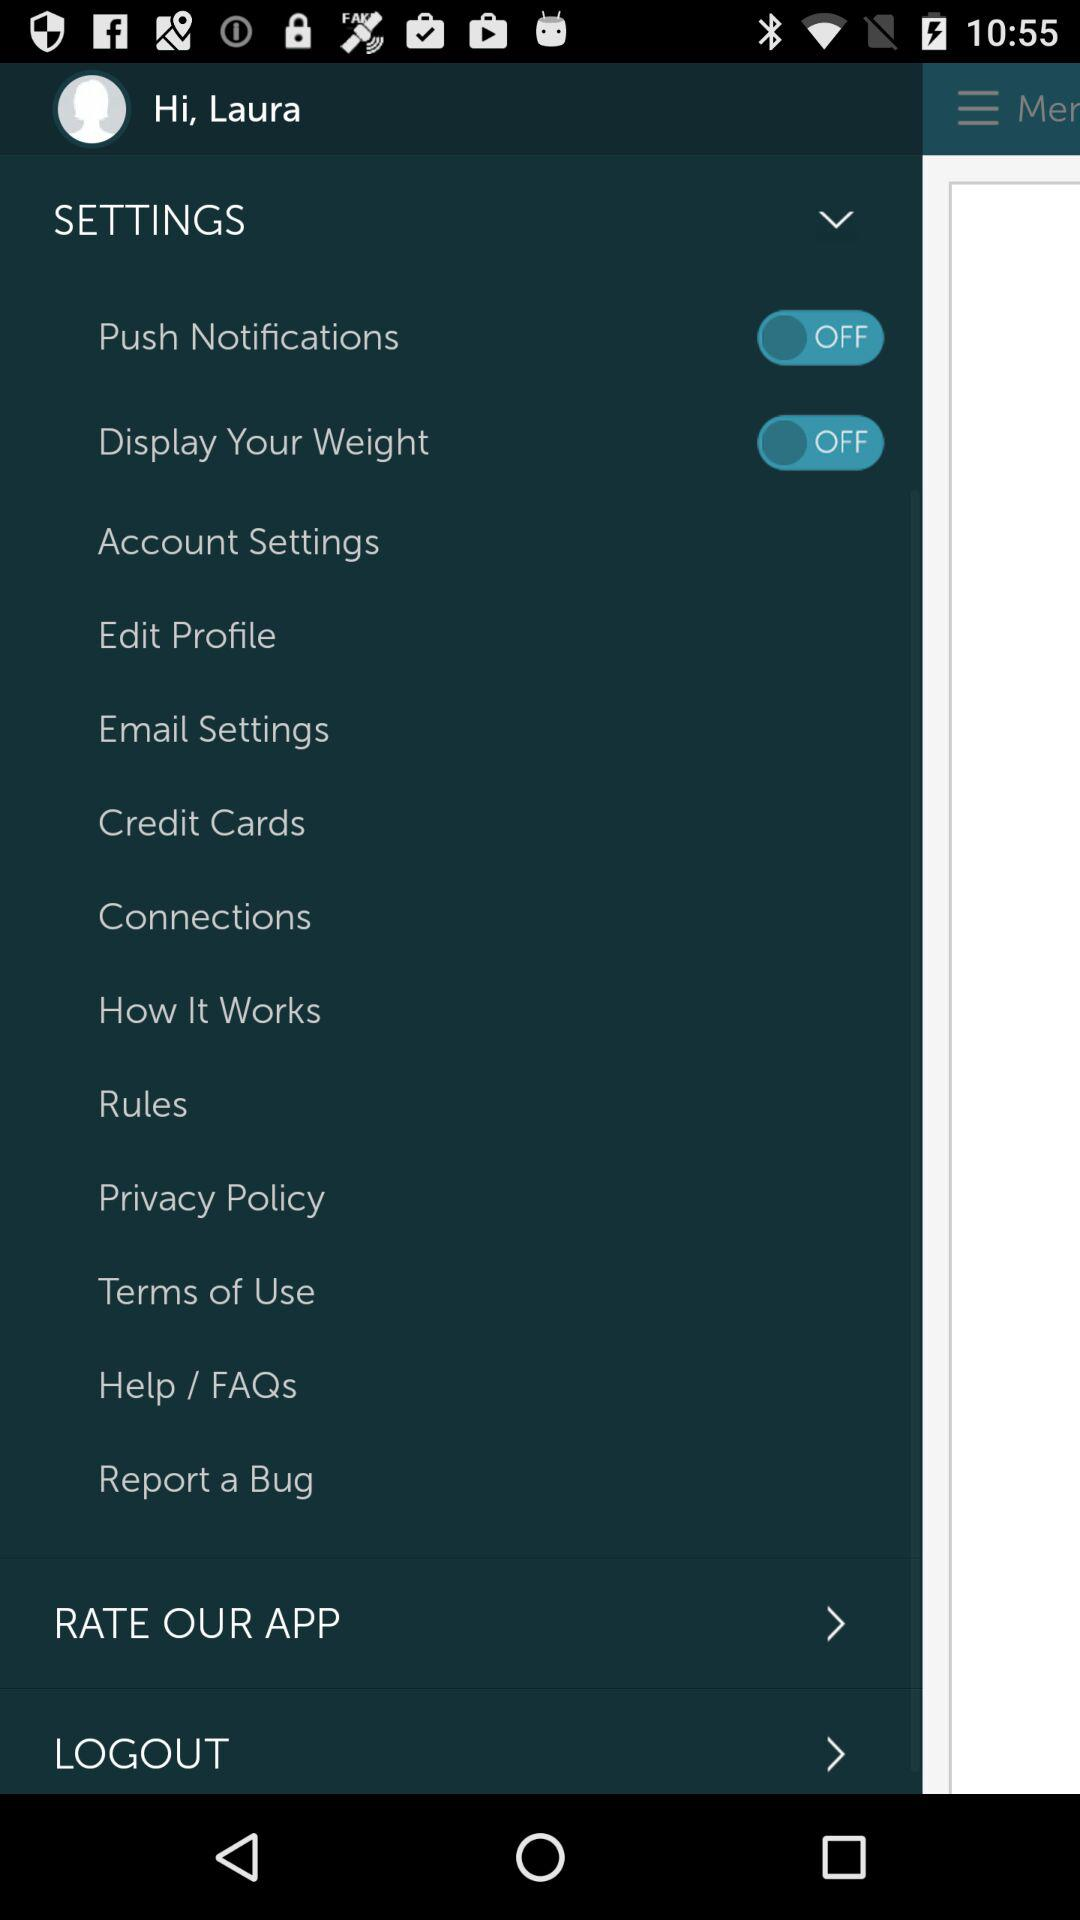What is the current status of "Push Notifications"? The current status of "Push Notifications" is "off". 